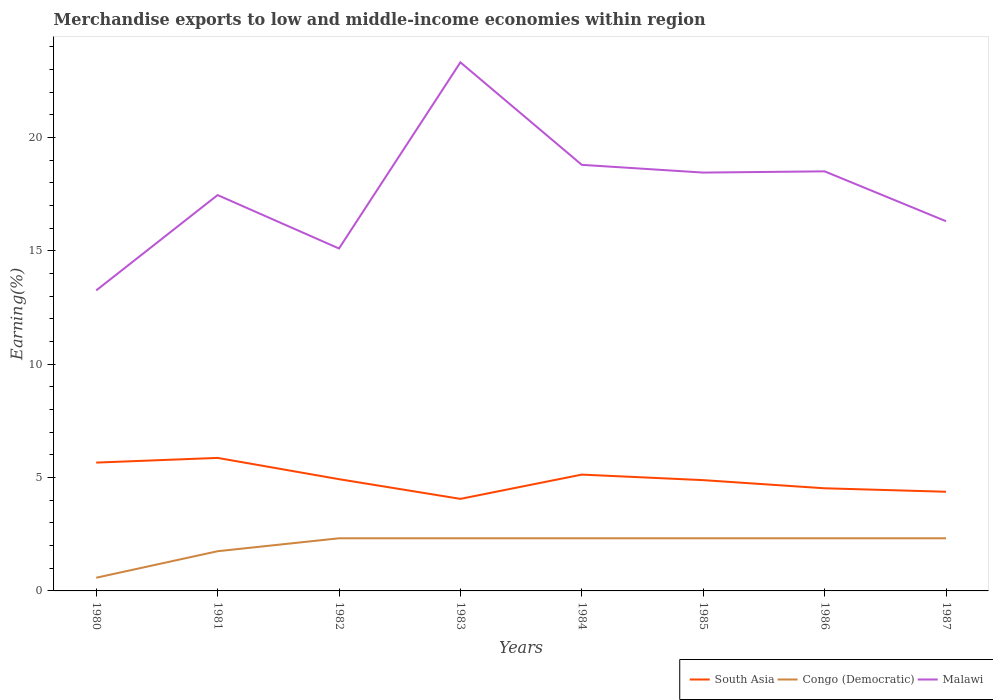How many different coloured lines are there?
Your answer should be very brief. 3. Does the line corresponding to Congo (Democratic) intersect with the line corresponding to South Asia?
Ensure brevity in your answer.  No. Across all years, what is the maximum percentage of amount earned from merchandise exports in South Asia?
Your response must be concise. 4.06. In which year was the percentage of amount earned from merchandise exports in South Asia maximum?
Provide a succinct answer. 1983. What is the total percentage of amount earned from merchandise exports in Congo (Democratic) in the graph?
Provide a short and direct response. 1.4108900714404626e-9. What is the difference between the highest and the second highest percentage of amount earned from merchandise exports in Malawi?
Keep it short and to the point. 10.06. How many lines are there?
Ensure brevity in your answer.  3. What is the difference between two consecutive major ticks on the Y-axis?
Keep it short and to the point. 5. Are the values on the major ticks of Y-axis written in scientific E-notation?
Your answer should be very brief. No. Where does the legend appear in the graph?
Ensure brevity in your answer.  Bottom right. What is the title of the graph?
Keep it short and to the point. Merchandise exports to low and middle-income economies within region. Does "Middle East & North Africa (all income levels)" appear as one of the legend labels in the graph?
Provide a short and direct response. No. What is the label or title of the Y-axis?
Ensure brevity in your answer.  Earning(%). What is the Earning(%) of South Asia in 1980?
Give a very brief answer. 5.66. What is the Earning(%) in Congo (Democratic) in 1980?
Keep it short and to the point. 0.58. What is the Earning(%) in Malawi in 1980?
Provide a short and direct response. 13.26. What is the Earning(%) in South Asia in 1981?
Make the answer very short. 5.87. What is the Earning(%) in Congo (Democratic) in 1981?
Provide a short and direct response. 1.75. What is the Earning(%) of Malawi in 1981?
Offer a terse response. 17.46. What is the Earning(%) in South Asia in 1982?
Offer a terse response. 4.93. What is the Earning(%) in Congo (Democratic) in 1982?
Make the answer very short. 2.32. What is the Earning(%) of Malawi in 1982?
Ensure brevity in your answer.  15.11. What is the Earning(%) of South Asia in 1983?
Provide a succinct answer. 4.06. What is the Earning(%) of Congo (Democratic) in 1983?
Your response must be concise. 2.32. What is the Earning(%) in Malawi in 1983?
Your response must be concise. 23.32. What is the Earning(%) of South Asia in 1984?
Make the answer very short. 5.13. What is the Earning(%) of Congo (Democratic) in 1984?
Keep it short and to the point. 2.32. What is the Earning(%) in Malawi in 1984?
Ensure brevity in your answer.  18.8. What is the Earning(%) of South Asia in 1985?
Your answer should be compact. 4.89. What is the Earning(%) of Congo (Democratic) in 1985?
Provide a short and direct response. 2.32. What is the Earning(%) in Malawi in 1985?
Provide a succinct answer. 18.45. What is the Earning(%) in South Asia in 1986?
Your response must be concise. 4.53. What is the Earning(%) in Congo (Democratic) in 1986?
Provide a short and direct response. 2.32. What is the Earning(%) of Malawi in 1986?
Offer a very short reply. 18.51. What is the Earning(%) in South Asia in 1987?
Offer a very short reply. 4.37. What is the Earning(%) of Congo (Democratic) in 1987?
Your answer should be compact. 2.32. What is the Earning(%) in Malawi in 1987?
Your answer should be very brief. 16.31. Across all years, what is the maximum Earning(%) of South Asia?
Provide a succinct answer. 5.87. Across all years, what is the maximum Earning(%) in Congo (Democratic)?
Offer a terse response. 2.32. Across all years, what is the maximum Earning(%) of Malawi?
Provide a succinct answer. 23.32. Across all years, what is the minimum Earning(%) in South Asia?
Provide a short and direct response. 4.06. Across all years, what is the minimum Earning(%) in Congo (Democratic)?
Provide a short and direct response. 0.58. Across all years, what is the minimum Earning(%) of Malawi?
Ensure brevity in your answer.  13.26. What is the total Earning(%) of South Asia in the graph?
Offer a terse response. 39.44. What is the total Earning(%) of Congo (Democratic) in the graph?
Ensure brevity in your answer.  16.26. What is the total Earning(%) in Malawi in the graph?
Give a very brief answer. 141.21. What is the difference between the Earning(%) in South Asia in 1980 and that in 1981?
Ensure brevity in your answer.  -0.21. What is the difference between the Earning(%) in Congo (Democratic) in 1980 and that in 1981?
Ensure brevity in your answer.  -1.17. What is the difference between the Earning(%) in Malawi in 1980 and that in 1981?
Offer a very short reply. -4.21. What is the difference between the Earning(%) in South Asia in 1980 and that in 1982?
Offer a very short reply. 0.73. What is the difference between the Earning(%) of Congo (Democratic) in 1980 and that in 1982?
Your answer should be compact. -1.74. What is the difference between the Earning(%) in Malawi in 1980 and that in 1982?
Your response must be concise. -1.85. What is the difference between the Earning(%) in South Asia in 1980 and that in 1983?
Your answer should be compact. 1.6. What is the difference between the Earning(%) in Congo (Democratic) in 1980 and that in 1983?
Make the answer very short. -1.74. What is the difference between the Earning(%) in Malawi in 1980 and that in 1983?
Make the answer very short. -10.06. What is the difference between the Earning(%) of South Asia in 1980 and that in 1984?
Provide a short and direct response. 0.53. What is the difference between the Earning(%) of Congo (Democratic) in 1980 and that in 1984?
Offer a very short reply. -1.74. What is the difference between the Earning(%) of Malawi in 1980 and that in 1984?
Provide a short and direct response. -5.54. What is the difference between the Earning(%) of South Asia in 1980 and that in 1985?
Give a very brief answer. 0.77. What is the difference between the Earning(%) of Congo (Democratic) in 1980 and that in 1985?
Give a very brief answer. -1.74. What is the difference between the Earning(%) in Malawi in 1980 and that in 1985?
Keep it short and to the point. -5.2. What is the difference between the Earning(%) of South Asia in 1980 and that in 1986?
Provide a succinct answer. 1.13. What is the difference between the Earning(%) of Congo (Democratic) in 1980 and that in 1986?
Ensure brevity in your answer.  -1.74. What is the difference between the Earning(%) of Malawi in 1980 and that in 1986?
Your answer should be compact. -5.25. What is the difference between the Earning(%) in South Asia in 1980 and that in 1987?
Give a very brief answer. 1.29. What is the difference between the Earning(%) in Congo (Democratic) in 1980 and that in 1987?
Give a very brief answer. -1.74. What is the difference between the Earning(%) of Malawi in 1980 and that in 1987?
Your answer should be very brief. -3.05. What is the difference between the Earning(%) of South Asia in 1981 and that in 1982?
Give a very brief answer. 0.94. What is the difference between the Earning(%) of Congo (Democratic) in 1981 and that in 1982?
Give a very brief answer. -0.57. What is the difference between the Earning(%) of Malawi in 1981 and that in 1982?
Give a very brief answer. 2.36. What is the difference between the Earning(%) of South Asia in 1981 and that in 1983?
Your response must be concise. 1.81. What is the difference between the Earning(%) of Congo (Democratic) in 1981 and that in 1983?
Your answer should be very brief. -0.57. What is the difference between the Earning(%) of Malawi in 1981 and that in 1983?
Your answer should be compact. -5.85. What is the difference between the Earning(%) in South Asia in 1981 and that in 1984?
Give a very brief answer. 0.74. What is the difference between the Earning(%) in Congo (Democratic) in 1981 and that in 1984?
Ensure brevity in your answer.  -0.57. What is the difference between the Earning(%) of Malawi in 1981 and that in 1984?
Your answer should be very brief. -1.33. What is the difference between the Earning(%) in South Asia in 1981 and that in 1985?
Your answer should be very brief. 0.98. What is the difference between the Earning(%) in Congo (Democratic) in 1981 and that in 1985?
Keep it short and to the point. -0.57. What is the difference between the Earning(%) in Malawi in 1981 and that in 1985?
Make the answer very short. -0.99. What is the difference between the Earning(%) in South Asia in 1981 and that in 1986?
Your response must be concise. 1.34. What is the difference between the Earning(%) in Congo (Democratic) in 1981 and that in 1986?
Your response must be concise. -0.57. What is the difference between the Earning(%) of Malawi in 1981 and that in 1986?
Provide a succinct answer. -1.05. What is the difference between the Earning(%) of South Asia in 1981 and that in 1987?
Provide a short and direct response. 1.49. What is the difference between the Earning(%) in Congo (Democratic) in 1981 and that in 1987?
Give a very brief answer. -0.57. What is the difference between the Earning(%) in Malawi in 1981 and that in 1987?
Provide a short and direct response. 1.15. What is the difference between the Earning(%) in South Asia in 1982 and that in 1983?
Keep it short and to the point. 0.87. What is the difference between the Earning(%) in Congo (Democratic) in 1982 and that in 1983?
Give a very brief answer. -0. What is the difference between the Earning(%) in Malawi in 1982 and that in 1983?
Keep it short and to the point. -8.21. What is the difference between the Earning(%) in South Asia in 1982 and that in 1984?
Provide a short and direct response. -0.2. What is the difference between the Earning(%) in Malawi in 1982 and that in 1984?
Offer a very short reply. -3.69. What is the difference between the Earning(%) in South Asia in 1982 and that in 1985?
Ensure brevity in your answer.  0.04. What is the difference between the Earning(%) of Malawi in 1982 and that in 1985?
Provide a succinct answer. -3.35. What is the difference between the Earning(%) in South Asia in 1982 and that in 1986?
Make the answer very short. 0.4. What is the difference between the Earning(%) in Malawi in 1982 and that in 1986?
Provide a short and direct response. -3.4. What is the difference between the Earning(%) of South Asia in 1982 and that in 1987?
Make the answer very short. 0.55. What is the difference between the Earning(%) of Congo (Democratic) in 1982 and that in 1987?
Offer a terse response. 0. What is the difference between the Earning(%) of Malawi in 1982 and that in 1987?
Your answer should be very brief. -1.2. What is the difference between the Earning(%) of South Asia in 1983 and that in 1984?
Your response must be concise. -1.07. What is the difference between the Earning(%) in Congo (Democratic) in 1983 and that in 1984?
Offer a terse response. -0. What is the difference between the Earning(%) in Malawi in 1983 and that in 1984?
Ensure brevity in your answer.  4.52. What is the difference between the Earning(%) in South Asia in 1983 and that in 1985?
Ensure brevity in your answer.  -0.83. What is the difference between the Earning(%) in Congo (Democratic) in 1983 and that in 1985?
Your answer should be very brief. 0. What is the difference between the Earning(%) in Malawi in 1983 and that in 1985?
Keep it short and to the point. 4.86. What is the difference between the Earning(%) in South Asia in 1983 and that in 1986?
Your response must be concise. -0.47. What is the difference between the Earning(%) in Malawi in 1983 and that in 1986?
Give a very brief answer. 4.81. What is the difference between the Earning(%) in South Asia in 1983 and that in 1987?
Provide a short and direct response. -0.31. What is the difference between the Earning(%) of Congo (Democratic) in 1983 and that in 1987?
Provide a short and direct response. 0. What is the difference between the Earning(%) in Malawi in 1983 and that in 1987?
Offer a terse response. 7.01. What is the difference between the Earning(%) in South Asia in 1984 and that in 1985?
Keep it short and to the point. 0.24. What is the difference between the Earning(%) in Congo (Democratic) in 1984 and that in 1985?
Provide a short and direct response. 0. What is the difference between the Earning(%) of Malawi in 1984 and that in 1985?
Ensure brevity in your answer.  0.34. What is the difference between the Earning(%) of South Asia in 1984 and that in 1986?
Give a very brief answer. 0.6. What is the difference between the Earning(%) of Congo (Democratic) in 1984 and that in 1986?
Provide a short and direct response. 0. What is the difference between the Earning(%) of Malawi in 1984 and that in 1986?
Offer a very short reply. 0.29. What is the difference between the Earning(%) in South Asia in 1984 and that in 1987?
Your answer should be very brief. 0.76. What is the difference between the Earning(%) of Congo (Democratic) in 1984 and that in 1987?
Make the answer very short. 0. What is the difference between the Earning(%) in Malawi in 1984 and that in 1987?
Ensure brevity in your answer.  2.49. What is the difference between the Earning(%) in South Asia in 1985 and that in 1986?
Your answer should be compact. 0.36. What is the difference between the Earning(%) of Congo (Democratic) in 1985 and that in 1986?
Give a very brief answer. -0. What is the difference between the Earning(%) of Malawi in 1985 and that in 1986?
Give a very brief answer. -0.05. What is the difference between the Earning(%) in South Asia in 1985 and that in 1987?
Your answer should be compact. 0.51. What is the difference between the Earning(%) of Congo (Democratic) in 1985 and that in 1987?
Your response must be concise. 0. What is the difference between the Earning(%) in Malawi in 1985 and that in 1987?
Provide a short and direct response. 2.14. What is the difference between the Earning(%) in South Asia in 1986 and that in 1987?
Give a very brief answer. 0.15. What is the difference between the Earning(%) in Congo (Democratic) in 1986 and that in 1987?
Your answer should be compact. 0. What is the difference between the Earning(%) in Malawi in 1986 and that in 1987?
Offer a terse response. 2.2. What is the difference between the Earning(%) in South Asia in 1980 and the Earning(%) in Congo (Democratic) in 1981?
Your answer should be compact. 3.91. What is the difference between the Earning(%) in South Asia in 1980 and the Earning(%) in Malawi in 1981?
Provide a short and direct response. -11.8. What is the difference between the Earning(%) in Congo (Democratic) in 1980 and the Earning(%) in Malawi in 1981?
Provide a short and direct response. -16.88. What is the difference between the Earning(%) of South Asia in 1980 and the Earning(%) of Congo (Democratic) in 1982?
Offer a terse response. 3.34. What is the difference between the Earning(%) in South Asia in 1980 and the Earning(%) in Malawi in 1982?
Ensure brevity in your answer.  -9.44. What is the difference between the Earning(%) in Congo (Democratic) in 1980 and the Earning(%) in Malawi in 1982?
Offer a terse response. -14.52. What is the difference between the Earning(%) of South Asia in 1980 and the Earning(%) of Congo (Democratic) in 1983?
Keep it short and to the point. 3.34. What is the difference between the Earning(%) in South Asia in 1980 and the Earning(%) in Malawi in 1983?
Provide a short and direct response. -17.66. What is the difference between the Earning(%) of Congo (Democratic) in 1980 and the Earning(%) of Malawi in 1983?
Provide a succinct answer. -22.74. What is the difference between the Earning(%) of South Asia in 1980 and the Earning(%) of Congo (Democratic) in 1984?
Provide a succinct answer. 3.34. What is the difference between the Earning(%) of South Asia in 1980 and the Earning(%) of Malawi in 1984?
Provide a succinct answer. -13.13. What is the difference between the Earning(%) in Congo (Democratic) in 1980 and the Earning(%) in Malawi in 1984?
Provide a succinct answer. -18.21. What is the difference between the Earning(%) of South Asia in 1980 and the Earning(%) of Congo (Democratic) in 1985?
Your answer should be compact. 3.34. What is the difference between the Earning(%) in South Asia in 1980 and the Earning(%) in Malawi in 1985?
Make the answer very short. -12.79. What is the difference between the Earning(%) in Congo (Democratic) in 1980 and the Earning(%) in Malawi in 1985?
Make the answer very short. -17.87. What is the difference between the Earning(%) of South Asia in 1980 and the Earning(%) of Congo (Democratic) in 1986?
Provide a short and direct response. 3.34. What is the difference between the Earning(%) in South Asia in 1980 and the Earning(%) in Malawi in 1986?
Your answer should be compact. -12.85. What is the difference between the Earning(%) of Congo (Democratic) in 1980 and the Earning(%) of Malawi in 1986?
Offer a very short reply. -17.93. What is the difference between the Earning(%) of South Asia in 1980 and the Earning(%) of Congo (Democratic) in 1987?
Your answer should be compact. 3.34. What is the difference between the Earning(%) in South Asia in 1980 and the Earning(%) in Malawi in 1987?
Ensure brevity in your answer.  -10.65. What is the difference between the Earning(%) of Congo (Democratic) in 1980 and the Earning(%) of Malawi in 1987?
Offer a very short reply. -15.73. What is the difference between the Earning(%) of South Asia in 1981 and the Earning(%) of Congo (Democratic) in 1982?
Offer a terse response. 3.55. What is the difference between the Earning(%) in South Asia in 1981 and the Earning(%) in Malawi in 1982?
Provide a succinct answer. -9.24. What is the difference between the Earning(%) of Congo (Democratic) in 1981 and the Earning(%) of Malawi in 1982?
Make the answer very short. -13.35. What is the difference between the Earning(%) in South Asia in 1981 and the Earning(%) in Congo (Democratic) in 1983?
Your answer should be compact. 3.55. What is the difference between the Earning(%) in South Asia in 1981 and the Earning(%) in Malawi in 1983?
Your answer should be very brief. -17.45. What is the difference between the Earning(%) of Congo (Democratic) in 1981 and the Earning(%) of Malawi in 1983?
Offer a terse response. -21.57. What is the difference between the Earning(%) of South Asia in 1981 and the Earning(%) of Congo (Democratic) in 1984?
Make the answer very short. 3.55. What is the difference between the Earning(%) of South Asia in 1981 and the Earning(%) of Malawi in 1984?
Offer a terse response. -12.93. What is the difference between the Earning(%) of Congo (Democratic) in 1981 and the Earning(%) of Malawi in 1984?
Make the answer very short. -17.04. What is the difference between the Earning(%) in South Asia in 1981 and the Earning(%) in Congo (Democratic) in 1985?
Keep it short and to the point. 3.55. What is the difference between the Earning(%) in South Asia in 1981 and the Earning(%) in Malawi in 1985?
Provide a succinct answer. -12.59. What is the difference between the Earning(%) in Congo (Democratic) in 1981 and the Earning(%) in Malawi in 1985?
Your answer should be very brief. -16.7. What is the difference between the Earning(%) in South Asia in 1981 and the Earning(%) in Congo (Democratic) in 1986?
Keep it short and to the point. 3.55. What is the difference between the Earning(%) of South Asia in 1981 and the Earning(%) of Malawi in 1986?
Ensure brevity in your answer.  -12.64. What is the difference between the Earning(%) of Congo (Democratic) in 1981 and the Earning(%) of Malawi in 1986?
Your answer should be compact. -16.76. What is the difference between the Earning(%) in South Asia in 1981 and the Earning(%) in Congo (Democratic) in 1987?
Offer a terse response. 3.55. What is the difference between the Earning(%) in South Asia in 1981 and the Earning(%) in Malawi in 1987?
Keep it short and to the point. -10.44. What is the difference between the Earning(%) in Congo (Democratic) in 1981 and the Earning(%) in Malawi in 1987?
Make the answer very short. -14.56. What is the difference between the Earning(%) of South Asia in 1982 and the Earning(%) of Congo (Democratic) in 1983?
Your response must be concise. 2.61. What is the difference between the Earning(%) in South Asia in 1982 and the Earning(%) in Malawi in 1983?
Provide a succinct answer. -18.39. What is the difference between the Earning(%) in Congo (Democratic) in 1982 and the Earning(%) in Malawi in 1983?
Your response must be concise. -20.99. What is the difference between the Earning(%) of South Asia in 1982 and the Earning(%) of Congo (Democratic) in 1984?
Ensure brevity in your answer.  2.61. What is the difference between the Earning(%) of South Asia in 1982 and the Earning(%) of Malawi in 1984?
Keep it short and to the point. -13.87. What is the difference between the Earning(%) in Congo (Democratic) in 1982 and the Earning(%) in Malawi in 1984?
Offer a very short reply. -16.47. What is the difference between the Earning(%) of South Asia in 1982 and the Earning(%) of Congo (Democratic) in 1985?
Provide a succinct answer. 2.61. What is the difference between the Earning(%) of South Asia in 1982 and the Earning(%) of Malawi in 1985?
Ensure brevity in your answer.  -13.52. What is the difference between the Earning(%) in Congo (Democratic) in 1982 and the Earning(%) in Malawi in 1985?
Make the answer very short. -16.13. What is the difference between the Earning(%) of South Asia in 1982 and the Earning(%) of Congo (Democratic) in 1986?
Provide a succinct answer. 2.61. What is the difference between the Earning(%) of South Asia in 1982 and the Earning(%) of Malawi in 1986?
Your answer should be very brief. -13.58. What is the difference between the Earning(%) of Congo (Democratic) in 1982 and the Earning(%) of Malawi in 1986?
Keep it short and to the point. -16.19. What is the difference between the Earning(%) in South Asia in 1982 and the Earning(%) in Congo (Democratic) in 1987?
Offer a very short reply. 2.61. What is the difference between the Earning(%) in South Asia in 1982 and the Earning(%) in Malawi in 1987?
Provide a short and direct response. -11.38. What is the difference between the Earning(%) in Congo (Democratic) in 1982 and the Earning(%) in Malawi in 1987?
Give a very brief answer. -13.99. What is the difference between the Earning(%) in South Asia in 1983 and the Earning(%) in Congo (Democratic) in 1984?
Provide a succinct answer. 1.74. What is the difference between the Earning(%) in South Asia in 1983 and the Earning(%) in Malawi in 1984?
Ensure brevity in your answer.  -14.73. What is the difference between the Earning(%) of Congo (Democratic) in 1983 and the Earning(%) of Malawi in 1984?
Keep it short and to the point. -16.47. What is the difference between the Earning(%) of South Asia in 1983 and the Earning(%) of Congo (Democratic) in 1985?
Give a very brief answer. 1.74. What is the difference between the Earning(%) in South Asia in 1983 and the Earning(%) in Malawi in 1985?
Make the answer very short. -14.39. What is the difference between the Earning(%) in Congo (Democratic) in 1983 and the Earning(%) in Malawi in 1985?
Provide a short and direct response. -16.13. What is the difference between the Earning(%) of South Asia in 1983 and the Earning(%) of Congo (Democratic) in 1986?
Ensure brevity in your answer.  1.74. What is the difference between the Earning(%) of South Asia in 1983 and the Earning(%) of Malawi in 1986?
Keep it short and to the point. -14.45. What is the difference between the Earning(%) in Congo (Democratic) in 1983 and the Earning(%) in Malawi in 1986?
Provide a succinct answer. -16.19. What is the difference between the Earning(%) of South Asia in 1983 and the Earning(%) of Congo (Democratic) in 1987?
Offer a very short reply. 1.74. What is the difference between the Earning(%) of South Asia in 1983 and the Earning(%) of Malawi in 1987?
Provide a succinct answer. -12.25. What is the difference between the Earning(%) of Congo (Democratic) in 1983 and the Earning(%) of Malawi in 1987?
Your response must be concise. -13.99. What is the difference between the Earning(%) of South Asia in 1984 and the Earning(%) of Congo (Democratic) in 1985?
Offer a very short reply. 2.81. What is the difference between the Earning(%) of South Asia in 1984 and the Earning(%) of Malawi in 1985?
Provide a succinct answer. -13.32. What is the difference between the Earning(%) of Congo (Democratic) in 1984 and the Earning(%) of Malawi in 1985?
Your answer should be very brief. -16.13. What is the difference between the Earning(%) in South Asia in 1984 and the Earning(%) in Congo (Democratic) in 1986?
Your response must be concise. 2.81. What is the difference between the Earning(%) of South Asia in 1984 and the Earning(%) of Malawi in 1986?
Your response must be concise. -13.38. What is the difference between the Earning(%) in Congo (Democratic) in 1984 and the Earning(%) in Malawi in 1986?
Ensure brevity in your answer.  -16.19. What is the difference between the Earning(%) of South Asia in 1984 and the Earning(%) of Congo (Democratic) in 1987?
Ensure brevity in your answer.  2.81. What is the difference between the Earning(%) of South Asia in 1984 and the Earning(%) of Malawi in 1987?
Make the answer very short. -11.18. What is the difference between the Earning(%) of Congo (Democratic) in 1984 and the Earning(%) of Malawi in 1987?
Make the answer very short. -13.99. What is the difference between the Earning(%) of South Asia in 1985 and the Earning(%) of Congo (Democratic) in 1986?
Offer a terse response. 2.56. What is the difference between the Earning(%) in South Asia in 1985 and the Earning(%) in Malawi in 1986?
Make the answer very short. -13.62. What is the difference between the Earning(%) in Congo (Democratic) in 1985 and the Earning(%) in Malawi in 1986?
Provide a short and direct response. -16.19. What is the difference between the Earning(%) of South Asia in 1985 and the Earning(%) of Congo (Democratic) in 1987?
Provide a succinct answer. 2.56. What is the difference between the Earning(%) in South Asia in 1985 and the Earning(%) in Malawi in 1987?
Give a very brief answer. -11.42. What is the difference between the Earning(%) in Congo (Democratic) in 1985 and the Earning(%) in Malawi in 1987?
Keep it short and to the point. -13.99. What is the difference between the Earning(%) in South Asia in 1986 and the Earning(%) in Congo (Democratic) in 1987?
Provide a succinct answer. 2.21. What is the difference between the Earning(%) of South Asia in 1986 and the Earning(%) of Malawi in 1987?
Provide a succinct answer. -11.78. What is the difference between the Earning(%) of Congo (Democratic) in 1986 and the Earning(%) of Malawi in 1987?
Ensure brevity in your answer.  -13.99. What is the average Earning(%) of South Asia per year?
Ensure brevity in your answer.  4.93. What is the average Earning(%) in Congo (Democratic) per year?
Provide a succinct answer. 2.03. What is the average Earning(%) in Malawi per year?
Give a very brief answer. 17.65. In the year 1980, what is the difference between the Earning(%) in South Asia and Earning(%) in Congo (Democratic)?
Your answer should be compact. 5.08. In the year 1980, what is the difference between the Earning(%) in South Asia and Earning(%) in Malawi?
Provide a short and direct response. -7.59. In the year 1980, what is the difference between the Earning(%) of Congo (Democratic) and Earning(%) of Malawi?
Your response must be concise. -12.67. In the year 1981, what is the difference between the Earning(%) in South Asia and Earning(%) in Congo (Democratic)?
Provide a short and direct response. 4.12. In the year 1981, what is the difference between the Earning(%) in South Asia and Earning(%) in Malawi?
Make the answer very short. -11.59. In the year 1981, what is the difference between the Earning(%) of Congo (Democratic) and Earning(%) of Malawi?
Offer a terse response. -15.71. In the year 1982, what is the difference between the Earning(%) of South Asia and Earning(%) of Congo (Democratic)?
Your answer should be very brief. 2.61. In the year 1982, what is the difference between the Earning(%) of South Asia and Earning(%) of Malawi?
Give a very brief answer. -10.18. In the year 1982, what is the difference between the Earning(%) in Congo (Democratic) and Earning(%) in Malawi?
Provide a succinct answer. -12.78. In the year 1983, what is the difference between the Earning(%) of South Asia and Earning(%) of Congo (Democratic)?
Your answer should be very brief. 1.74. In the year 1983, what is the difference between the Earning(%) of South Asia and Earning(%) of Malawi?
Ensure brevity in your answer.  -19.26. In the year 1983, what is the difference between the Earning(%) of Congo (Democratic) and Earning(%) of Malawi?
Give a very brief answer. -20.99. In the year 1984, what is the difference between the Earning(%) of South Asia and Earning(%) of Congo (Democratic)?
Provide a short and direct response. 2.81. In the year 1984, what is the difference between the Earning(%) in South Asia and Earning(%) in Malawi?
Ensure brevity in your answer.  -13.66. In the year 1984, what is the difference between the Earning(%) in Congo (Democratic) and Earning(%) in Malawi?
Your answer should be very brief. -16.47. In the year 1985, what is the difference between the Earning(%) in South Asia and Earning(%) in Congo (Democratic)?
Make the answer very short. 2.56. In the year 1985, what is the difference between the Earning(%) in South Asia and Earning(%) in Malawi?
Your response must be concise. -13.57. In the year 1985, what is the difference between the Earning(%) in Congo (Democratic) and Earning(%) in Malawi?
Your response must be concise. -16.13. In the year 1986, what is the difference between the Earning(%) of South Asia and Earning(%) of Congo (Democratic)?
Keep it short and to the point. 2.21. In the year 1986, what is the difference between the Earning(%) of South Asia and Earning(%) of Malawi?
Your response must be concise. -13.98. In the year 1986, what is the difference between the Earning(%) of Congo (Democratic) and Earning(%) of Malawi?
Offer a terse response. -16.19. In the year 1987, what is the difference between the Earning(%) of South Asia and Earning(%) of Congo (Democratic)?
Offer a very short reply. 2.05. In the year 1987, what is the difference between the Earning(%) of South Asia and Earning(%) of Malawi?
Your answer should be compact. -11.93. In the year 1987, what is the difference between the Earning(%) of Congo (Democratic) and Earning(%) of Malawi?
Ensure brevity in your answer.  -13.99. What is the ratio of the Earning(%) of South Asia in 1980 to that in 1981?
Keep it short and to the point. 0.96. What is the ratio of the Earning(%) in Congo (Democratic) in 1980 to that in 1981?
Provide a short and direct response. 0.33. What is the ratio of the Earning(%) of Malawi in 1980 to that in 1981?
Ensure brevity in your answer.  0.76. What is the ratio of the Earning(%) in South Asia in 1980 to that in 1982?
Offer a very short reply. 1.15. What is the ratio of the Earning(%) in Congo (Democratic) in 1980 to that in 1982?
Give a very brief answer. 0.25. What is the ratio of the Earning(%) of Malawi in 1980 to that in 1982?
Make the answer very short. 0.88. What is the ratio of the Earning(%) of South Asia in 1980 to that in 1983?
Give a very brief answer. 1.39. What is the ratio of the Earning(%) in Congo (Democratic) in 1980 to that in 1983?
Offer a very short reply. 0.25. What is the ratio of the Earning(%) of Malawi in 1980 to that in 1983?
Make the answer very short. 0.57. What is the ratio of the Earning(%) of South Asia in 1980 to that in 1984?
Ensure brevity in your answer.  1.1. What is the ratio of the Earning(%) of Congo (Democratic) in 1980 to that in 1984?
Keep it short and to the point. 0.25. What is the ratio of the Earning(%) of Malawi in 1980 to that in 1984?
Your response must be concise. 0.71. What is the ratio of the Earning(%) of South Asia in 1980 to that in 1985?
Give a very brief answer. 1.16. What is the ratio of the Earning(%) in Congo (Democratic) in 1980 to that in 1985?
Provide a succinct answer. 0.25. What is the ratio of the Earning(%) in Malawi in 1980 to that in 1985?
Your response must be concise. 0.72. What is the ratio of the Earning(%) of South Asia in 1980 to that in 1986?
Offer a very short reply. 1.25. What is the ratio of the Earning(%) of Congo (Democratic) in 1980 to that in 1986?
Keep it short and to the point. 0.25. What is the ratio of the Earning(%) in Malawi in 1980 to that in 1986?
Provide a short and direct response. 0.72. What is the ratio of the Earning(%) in South Asia in 1980 to that in 1987?
Offer a very short reply. 1.29. What is the ratio of the Earning(%) in Congo (Democratic) in 1980 to that in 1987?
Provide a succinct answer. 0.25. What is the ratio of the Earning(%) in Malawi in 1980 to that in 1987?
Keep it short and to the point. 0.81. What is the ratio of the Earning(%) in South Asia in 1981 to that in 1982?
Make the answer very short. 1.19. What is the ratio of the Earning(%) of Congo (Democratic) in 1981 to that in 1982?
Your answer should be very brief. 0.75. What is the ratio of the Earning(%) of Malawi in 1981 to that in 1982?
Your response must be concise. 1.16. What is the ratio of the Earning(%) in South Asia in 1981 to that in 1983?
Give a very brief answer. 1.45. What is the ratio of the Earning(%) of Congo (Democratic) in 1981 to that in 1983?
Provide a short and direct response. 0.75. What is the ratio of the Earning(%) in Malawi in 1981 to that in 1983?
Keep it short and to the point. 0.75. What is the ratio of the Earning(%) in South Asia in 1981 to that in 1984?
Ensure brevity in your answer.  1.14. What is the ratio of the Earning(%) in Congo (Democratic) in 1981 to that in 1984?
Give a very brief answer. 0.75. What is the ratio of the Earning(%) in Malawi in 1981 to that in 1984?
Give a very brief answer. 0.93. What is the ratio of the Earning(%) in South Asia in 1981 to that in 1985?
Offer a very short reply. 1.2. What is the ratio of the Earning(%) of Congo (Democratic) in 1981 to that in 1985?
Your answer should be compact. 0.75. What is the ratio of the Earning(%) in Malawi in 1981 to that in 1985?
Provide a short and direct response. 0.95. What is the ratio of the Earning(%) in South Asia in 1981 to that in 1986?
Give a very brief answer. 1.3. What is the ratio of the Earning(%) in Congo (Democratic) in 1981 to that in 1986?
Give a very brief answer. 0.75. What is the ratio of the Earning(%) of Malawi in 1981 to that in 1986?
Provide a short and direct response. 0.94. What is the ratio of the Earning(%) in South Asia in 1981 to that in 1987?
Make the answer very short. 1.34. What is the ratio of the Earning(%) in Congo (Democratic) in 1981 to that in 1987?
Your response must be concise. 0.75. What is the ratio of the Earning(%) of Malawi in 1981 to that in 1987?
Keep it short and to the point. 1.07. What is the ratio of the Earning(%) of South Asia in 1982 to that in 1983?
Give a very brief answer. 1.21. What is the ratio of the Earning(%) in Malawi in 1982 to that in 1983?
Your response must be concise. 0.65. What is the ratio of the Earning(%) in South Asia in 1982 to that in 1984?
Your response must be concise. 0.96. What is the ratio of the Earning(%) of Congo (Democratic) in 1982 to that in 1984?
Give a very brief answer. 1. What is the ratio of the Earning(%) of Malawi in 1982 to that in 1984?
Your answer should be very brief. 0.8. What is the ratio of the Earning(%) of South Asia in 1982 to that in 1985?
Make the answer very short. 1.01. What is the ratio of the Earning(%) of Malawi in 1982 to that in 1985?
Offer a terse response. 0.82. What is the ratio of the Earning(%) in South Asia in 1982 to that in 1986?
Offer a terse response. 1.09. What is the ratio of the Earning(%) in Congo (Democratic) in 1982 to that in 1986?
Offer a terse response. 1. What is the ratio of the Earning(%) of Malawi in 1982 to that in 1986?
Your answer should be compact. 0.82. What is the ratio of the Earning(%) of South Asia in 1982 to that in 1987?
Provide a succinct answer. 1.13. What is the ratio of the Earning(%) of Congo (Democratic) in 1982 to that in 1987?
Offer a terse response. 1. What is the ratio of the Earning(%) of Malawi in 1982 to that in 1987?
Provide a succinct answer. 0.93. What is the ratio of the Earning(%) of South Asia in 1983 to that in 1984?
Offer a terse response. 0.79. What is the ratio of the Earning(%) in Malawi in 1983 to that in 1984?
Offer a terse response. 1.24. What is the ratio of the Earning(%) of South Asia in 1983 to that in 1985?
Keep it short and to the point. 0.83. What is the ratio of the Earning(%) of Congo (Democratic) in 1983 to that in 1985?
Your answer should be very brief. 1. What is the ratio of the Earning(%) in Malawi in 1983 to that in 1985?
Make the answer very short. 1.26. What is the ratio of the Earning(%) of South Asia in 1983 to that in 1986?
Give a very brief answer. 0.9. What is the ratio of the Earning(%) of Congo (Democratic) in 1983 to that in 1986?
Ensure brevity in your answer.  1. What is the ratio of the Earning(%) of Malawi in 1983 to that in 1986?
Give a very brief answer. 1.26. What is the ratio of the Earning(%) of South Asia in 1983 to that in 1987?
Give a very brief answer. 0.93. What is the ratio of the Earning(%) in Congo (Democratic) in 1983 to that in 1987?
Offer a terse response. 1. What is the ratio of the Earning(%) in Malawi in 1983 to that in 1987?
Your answer should be compact. 1.43. What is the ratio of the Earning(%) of Malawi in 1984 to that in 1985?
Keep it short and to the point. 1.02. What is the ratio of the Earning(%) of South Asia in 1984 to that in 1986?
Ensure brevity in your answer.  1.13. What is the ratio of the Earning(%) of Congo (Democratic) in 1984 to that in 1986?
Your answer should be compact. 1. What is the ratio of the Earning(%) of Malawi in 1984 to that in 1986?
Offer a terse response. 1.02. What is the ratio of the Earning(%) of South Asia in 1984 to that in 1987?
Ensure brevity in your answer.  1.17. What is the ratio of the Earning(%) of Malawi in 1984 to that in 1987?
Provide a succinct answer. 1.15. What is the ratio of the Earning(%) of South Asia in 1985 to that in 1986?
Offer a terse response. 1.08. What is the ratio of the Earning(%) of Congo (Democratic) in 1985 to that in 1986?
Give a very brief answer. 1. What is the ratio of the Earning(%) of Malawi in 1985 to that in 1986?
Ensure brevity in your answer.  1. What is the ratio of the Earning(%) of South Asia in 1985 to that in 1987?
Give a very brief answer. 1.12. What is the ratio of the Earning(%) in Congo (Democratic) in 1985 to that in 1987?
Ensure brevity in your answer.  1. What is the ratio of the Earning(%) in Malawi in 1985 to that in 1987?
Offer a very short reply. 1.13. What is the ratio of the Earning(%) of South Asia in 1986 to that in 1987?
Offer a terse response. 1.03. What is the ratio of the Earning(%) in Malawi in 1986 to that in 1987?
Your answer should be very brief. 1.13. What is the difference between the highest and the second highest Earning(%) of South Asia?
Give a very brief answer. 0.21. What is the difference between the highest and the second highest Earning(%) of Congo (Democratic)?
Offer a terse response. 0. What is the difference between the highest and the second highest Earning(%) in Malawi?
Your answer should be very brief. 4.52. What is the difference between the highest and the lowest Earning(%) in South Asia?
Give a very brief answer. 1.81. What is the difference between the highest and the lowest Earning(%) in Congo (Democratic)?
Offer a very short reply. 1.74. What is the difference between the highest and the lowest Earning(%) in Malawi?
Provide a short and direct response. 10.06. 